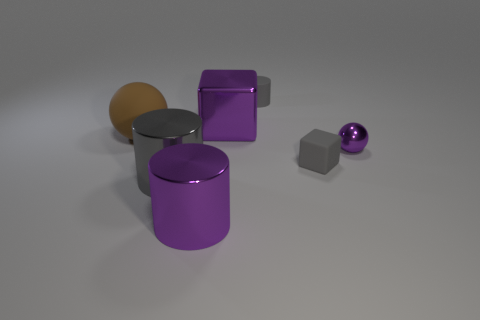Can you describe the different shapes and how they are arranged in the image? Certainly! The image features a collection of geometric shapes arranged on a flat surface. There are two cylindrical objects, one purple and one orange; the purple one is standing upright while the orange is on its side. There's also a reflective gray cube and a small reflective purple sphere. Overall, the shapes are spaced out in an asymmetrical, visually pleasing manner. 